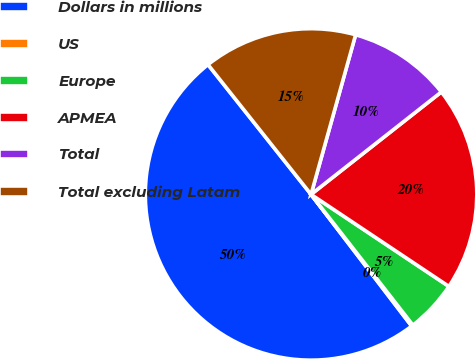Convert chart. <chart><loc_0><loc_0><loc_500><loc_500><pie_chart><fcel>Dollars in millions<fcel>US<fcel>Europe<fcel>APMEA<fcel>Total<fcel>Total excluding Latam<nl><fcel>49.7%<fcel>0.15%<fcel>5.1%<fcel>19.97%<fcel>10.06%<fcel>15.01%<nl></chart> 